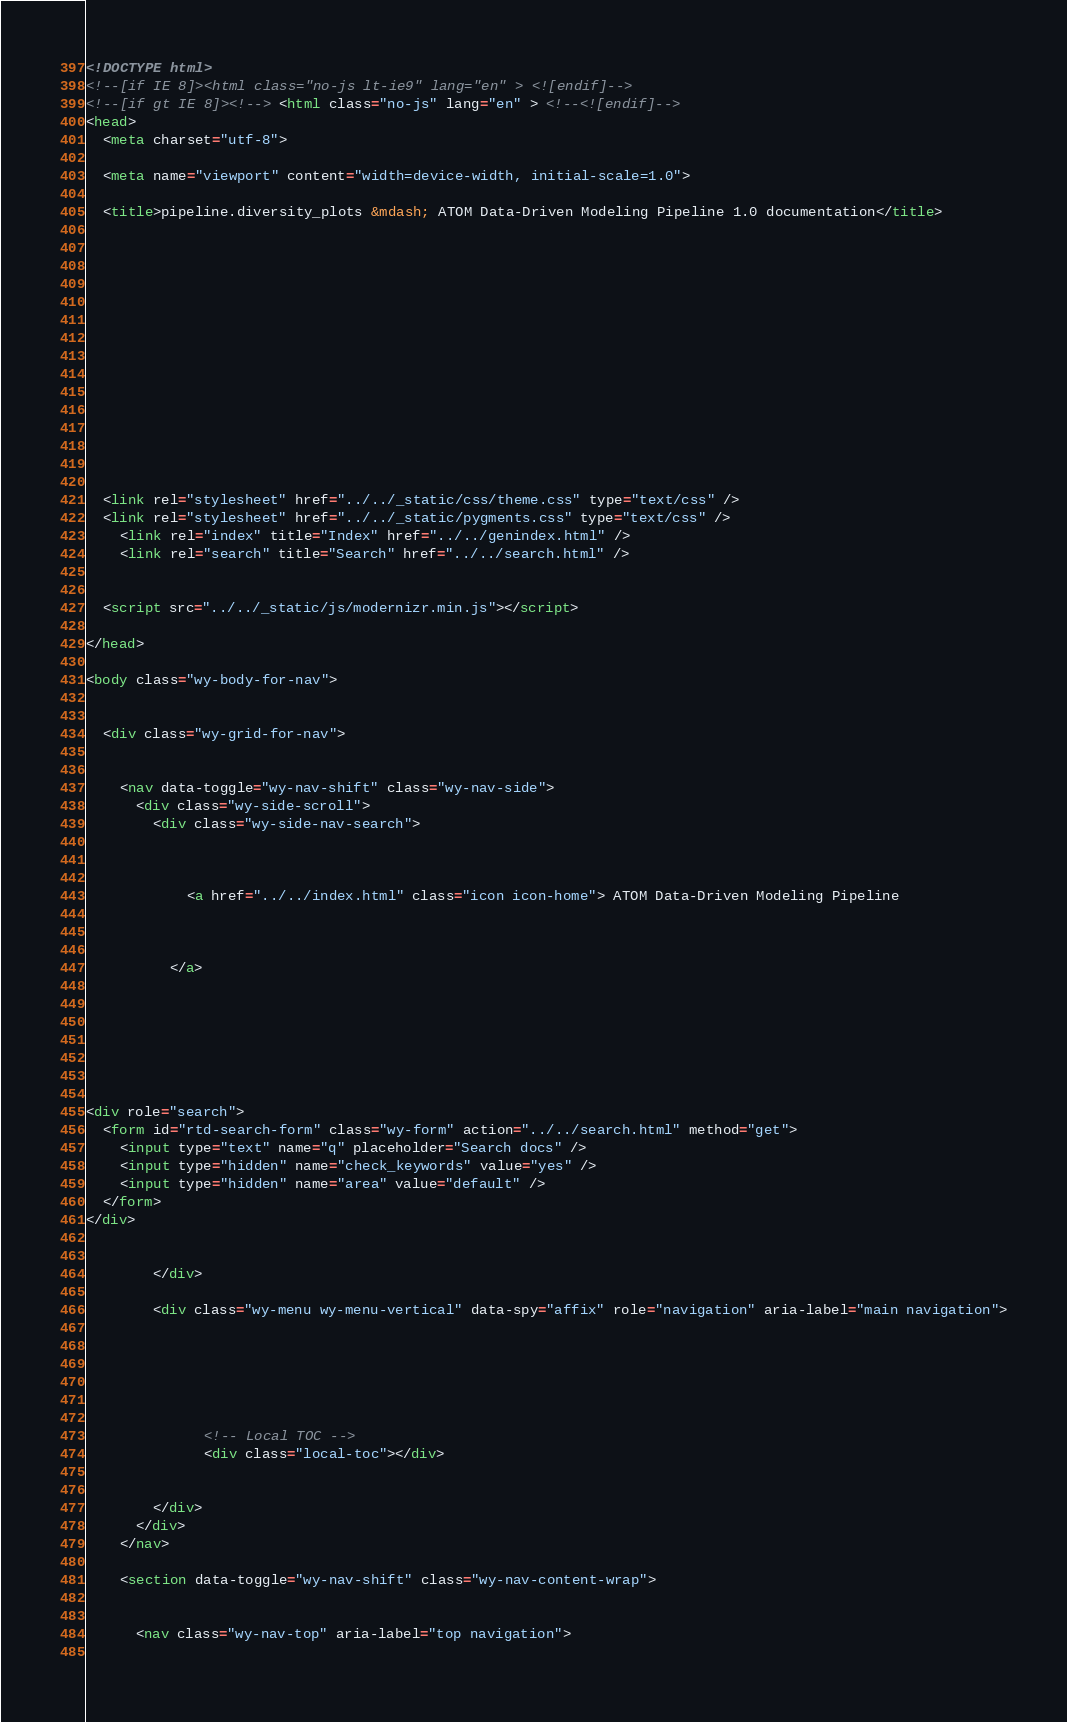<code> <loc_0><loc_0><loc_500><loc_500><_HTML_>

<!DOCTYPE html>
<!--[if IE 8]><html class="no-js lt-ie9" lang="en" > <![endif]-->
<!--[if gt IE 8]><!--> <html class="no-js" lang="en" > <!--<![endif]-->
<head>
  <meta charset="utf-8">
  
  <meta name="viewport" content="width=device-width, initial-scale=1.0">
  
  <title>pipeline.diversity_plots &mdash; ATOM Data-Driven Modeling Pipeline 1.0 documentation</title>
  

  
  
  
  

  

  
  
    

  

  <link rel="stylesheet" href="../../_static/css/theme.css" type="text/css" />
  <link rel="stylesheet" href="../../_static/pygments.css" type="text/css" />
    <link rel="index" title="Index" href="../../genindex.html" />
    <link rel="search" title="Search" href="../../search.html" /> 

  
  <script src="../../_static/js/modernizr.min.js"></script>

</head>

<body class="wy-body-for-nav">

   
  <div class="wy-grid-for-nav">

    
    <nav data-toggle="wy-nav-shift" class="wy-nav-side">
      <div class="wy-side-scroll">
        <div class="wy-side-nav-search">
          

          
            <a href="../../index.html" class="icon icon-home"> ATOM Data-Driven Modeling Pipeline
          

          
          </a>

          
            
            
          

          
<div role="search">
  <form id="rtd-search-form" class="wy-form" action="../../search.html" method="get">
    <input type="text" name="q" placeholder="Search docs" />
    <input type="hidden" name="check_keywords" value="yes" />
    <input type="hidden" name="area" value="default" />
  </form>
</div>

          
        </div>

        <div class="wy-menu wy-menu-vertical" data-spy="affix" role="navigation" aria-label="main navigation">
          
            
            
              
            
            
              <!-- Local TOC -->
              <div class="local-toc"></div>
            
          
        </div>
      </div>
    </nav>

    <section data-toggle="wy-nav-shift" class="wy-nav-content-wrap">

      
      <nav class="wy-nav-top" aria-label="top navigation">
        </code> 